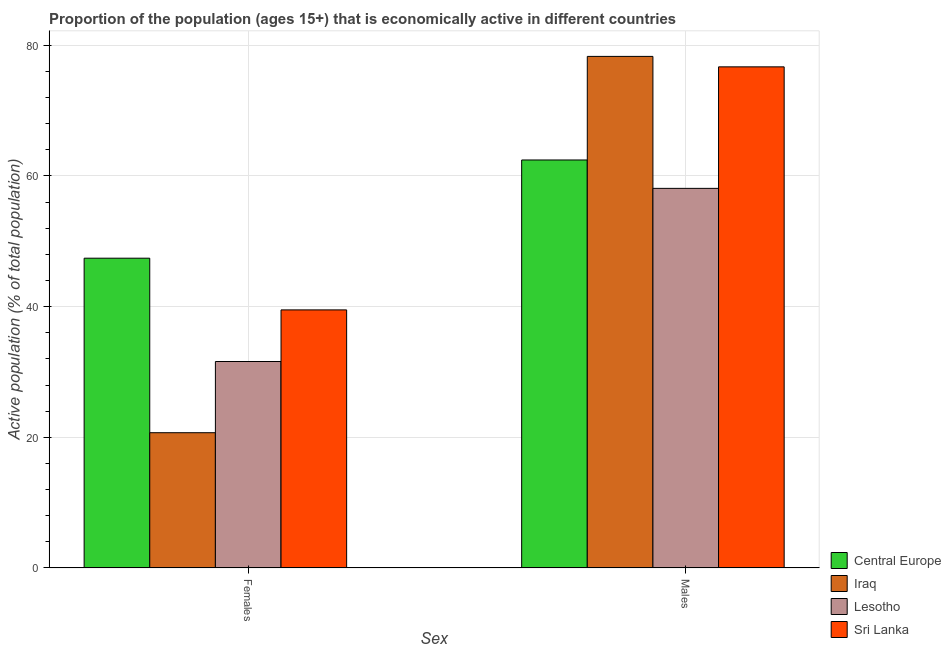How many groups of bars are there?
Offer a very short reply. 2. Are the number of bars per tick equal to the number of legend labels?
Give a very brief answer. Yes. How many bars are there on the 1st tick from the left?
Your response must be concise. 4. How many bars are there on the 2nd tick from the right?
Offer a very short reply. 4. What is the label of the 2nd group of bars from the left?
Give a very brief answer. Males. What is the percentage of economically active male population in Sri Lanka?
Make the answer very short. 76.7. Across all countries, what is the maximum percentage of economically active male population?
Provide a succinct answer. 78.3. Across all countries, what is the minimum percentage of economically active female population?
Keep it short and to the point. 20.7. In which country was the percentage of economically active male population maximum?
Make the answer very short. Iraq. In which country was the percentage of economically active female population minimum?
Provide a succinct answer. Iraq. What is the total percentage of economically active male population in the graph?
Provide a short and direct response. 275.55. What is the difference between the percentage of economically active female population in Lesotho and that in Central Europe?
Offer a very short reply. -15.81. What is the difference between the percentage of economically active female population in Sri Lanka and the percentage of economically active male population in Central Europe?
Your response must be concise. -22.95. What is the average percentage of economically active male population per country?
Offer a terse response. 68.89. What is the difference between the percentage of economically active male population and percentage of economically active female population in Iraq?
Make the answer very short. 57.6. What is the ratio of the percentage of economically active male population in Iraq to that in Lesotho?
Keep it short and to the point. 1.35. Is the percentage of economically active male population in Iraq less than that in Lesotho?
Provide a short and direct response. No. In how many countries, is the percentage of economically active male population greater than the average percentage of economically active male population taken over all countries?
Ensure brevity in your answer.  2. What does the 4th bar from the left in Males represents?
Your response must be concise. Sri Lanka. What does the 1st bar from the right in Females represents?
Make the answer very short. Sri Lanka. How many bars are there?
Offer a terse response. 8. Are all the bars in the graph horizontal?
Ensure brevity in your answer.  No. Are the values on the major ticks of Y-axis written in scientific E-notation?
Ensure brevity in your answer.  No. Does the graph contain grids?
Your answer should be compact. Yes. What is the title of the graph?
Your response must be concise. Proportion of the population (ages 15+) that is economically active in different countries. What is the label or title of the X-axis?
Your answer should be compact. Sex. What is the label or title of the Y-axis?
Your answer should be compact. Active population (% of total population). What is the Active population (% of total population) of Central Europe in Females?
Provide a short and direct response. 47.41. What is the Active population (% of total population) in Iraq in Females?
Offer a very short reply. 20.7. What is the Active population (% of total population) in Lesotho in Females?
Ensure brevity in your answer.  31.6. What is the Active population (% of total population) in Sri Lanka in Females?
Offer a terse response. 39.5. What is the Active population (% of total population) of Central Europe in Males?
Keep it short and to the point. 62.45. What is the Active population (% of total population) in Iraq in Males?
Keep it short and to the point. 78.3. What is the Active population (% of total population) in Lesotho in Males?
Give a very brief answer. 58.1. What is the Active population (% of total population) in Sri Lanka in Males?
Offer a very short reply. 76.7. Across all Sex, what is the maximum Active population (% of total population) in Central Europe?
Offer a terse response. 62.45. Across all Sex, what is the maximum Active population (% of total population) in Iraq?
Your answer should be compact. 78.3. Across all Sex, what is the maximum Active population (% of total population) in Lesotho?
Make the answer very short. 58.1. Across all Sex, what is the maximum Active population (% of total population) of Sri Lanka?
Your answer should be compact. 76.7. Across all Sex, what is the minimum Active population (% of total population) in Central Europe?
Keep it short and to the point. 47.41. Across all Sex, what is the minimum Active population (% of total population) of Iraq?
Your answer should be compact. 20.7. Across all Sex, what is the minimum Active population (% of total population) in Lesotho?
Offer a terse response. 31.6. Across all Sex, what is the minimum Active population (% of total population) of Sri Lanka?
Offer a terse response. 39.5. What is the total Active population (% of total population) of Central Europe in the graph?
Keep it short and to the point. 109.86. What is the total Active population (% of total population) in Lesotho in the graph?
Give a very brief answer. 89.7. What is the total Active population (% of total population) in Sri Lanka in the graph?
Give a very brief answer. 116.2. What is the difference between the Active population (% of total population) in Central Europe in Females and that in Males?
Ensure brevity in your answer.  -15.03. What is the difference between the Active population (% of total population) in Iraq in Females and that in Males?
Your answer should be very brief. -57.6. What is the difference between the Active population (% of total population) in Lesotho in Females and that in Males?
Ensure brevity in your answer.  -26.5. What is the difference between the Active population (% of total population) of Sri Lanka in Females and that in Males?
Offer a very short reply. -37.2. What is the difference between the Active population (% of total population) of Central Europe in Females and the Active population (% of total population) of Iraq in Males?
Give a very brief answer. -30.89. What is the difference between the Active population (% of total population) in Central Europe in Females and the Active population (% of total population) in Lesotho in Males?
Your answer should be compact. -10.69. What is the difference between the Active population (% of total population) in Central Europe in Females and the Active population (% of total population) in Sri Lanka in Males?
Your response must be concise. -29.29. What is the difference between the Active population (% of total population) in Iraq in Females and the Active population (% of total population) in Lesotho in Males?
Your answer should be very brief. -37.4. What is the difference between the Active population (% of total population) of Iraq in Females and the Active population (% of total population) of Sri Lanka in Males?
Your answer should be very brief. -56. What is the difference between the Active population (% of total population) in Lesotho in Females and the Active population (% of total population) in Sri Lanka in Males?
Offer a very short reply. -45.1. What is the average Active population (% of total population) of Central Europe per Sex?
Make the answer very short. 54.93. What is the average Active population (% of total population) in Iraq per Sex?
Offer a terse response. 49.5. What is the average Active population (% of total population) of Lesotho per Sex?
Keep it short and to the point. 44.85. What is the average Active population (% of total population) of Sri Lanka per Sex?
Your answer should be compact. 58.1. What is the difference between the Active population (% of total population) in Central Europe and Active population (% of total population) in Iraq in Females?
Provide a short and direct response. 26.71. What is the difference between the Active population (% of total population) of Central Europe and Active population (% of total population) of Lesotho in Females?
Ensure brevity in your answer.  15.81. What is the difference between the Active population (% of total population) in Central Europe and Active population (% of total population) in Sri Lanka in Females?
Provide a short and direct response. 7.91. What is the difference between the Active population (% of total population) in Iraq and Active population (% of total population) in Sri Lanka in Females?
Your answer should be very brief. -18.8. What is the difference between the Active population (% of total population) in Central Europe and Active population (% of total population) in Iraq in Males?
Give a very brief answer. -15.85. What is the difference between the Active population (% of total population) of Central Europe and Active population (% of total population) of Lesotho in Males?
Provide a succinct answer. 4.35. What is the difference between the Active population (% of total population) in Central Europe and Active population (% of total population) in Sri Lanka in Males?
Provide a short and direct response. -14.25. What is the difference between the Active population (% of total population) of Iraq and Active population (% of total population) of Lesotho in Males?
Make the answer very short. 20.2. What is the difference between the Active population (% of total population) in Lesotho and Active population (% of total population) in Sri Lanka in Males?
Keep it short and to the point. -18.6. What is the ratio of the Active population (% of total population) in Central Europe in Females to that in Males?
Make the answer very short. 0.76. What is the ratio of the Active population (% of total population) of Iraq in Females to that in Males?
Ensure brevity in your answer.  0.26. What is the ratio of the Active population (% of total population) of Lesotho in Females to that in Males?
Give a very brief answer. 0.54. What is the ratio of the Active population (% of total population) in Sri Lanka in Females to that in Males?
Offer a terse response. 0.52. What is the difference between the highest and the second highest Active population (% of total population) in Central Europe?
Make the answer very short. 15.03. What is the difference between the highest and the second highest Active population (% of total population) of Iraq?
Provide a succinct answer. 57.6. What is the difference between the highest and the second highest Active population (% of total population) in Lesotho?
Ensure brevity in your answer.  26.5. What is the difference between the highest and the second highest Active population (% of total population) in Sri Lanka?
Ensure brevity in your answer.  37.2. What is the difference between the highest and the lowest Active population (% of total population) of Central Europe?
Offer a very short reply. 15.03. What is the difference between the highest and the lowest Active population (% of total population) of Iraq?
Keep it short and to the point. 57.6. What is the difference between the highest and the lowest Active population (% of total population) of Sri Lanka?
Your answer should be very brief. 37.2. 